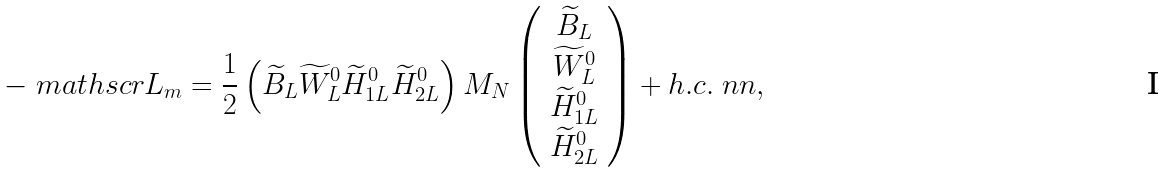Convert formula to latex. <formula><loc_0><loc_0><loc_500><loc_500>- \ m a t h s c r { L } _ { m } = \frac { 1 } { 2 } \left ( { \widetilde { B } } _ { L } { \widetilde { W } } ^ { 0 } _ { L } { \widetilde { H } } ^ { 0 } _ { 1 L } { \widetilde { H } } ^ { 0 } _ { 2 L } \right ) M _ { N } \left ( \begin{array} { c } { \widetilde { B } } _ { L } \\ { \widetilde { W } } ^ { 0 } _ { L } \\ { \widetilde { H } } ^ { 0 } _ { 1 L } \\ { \widetilde { H } } ^ { 0 } _ { 2 L } \end{array} \right ) + h . c . \ n n ,</formula> 